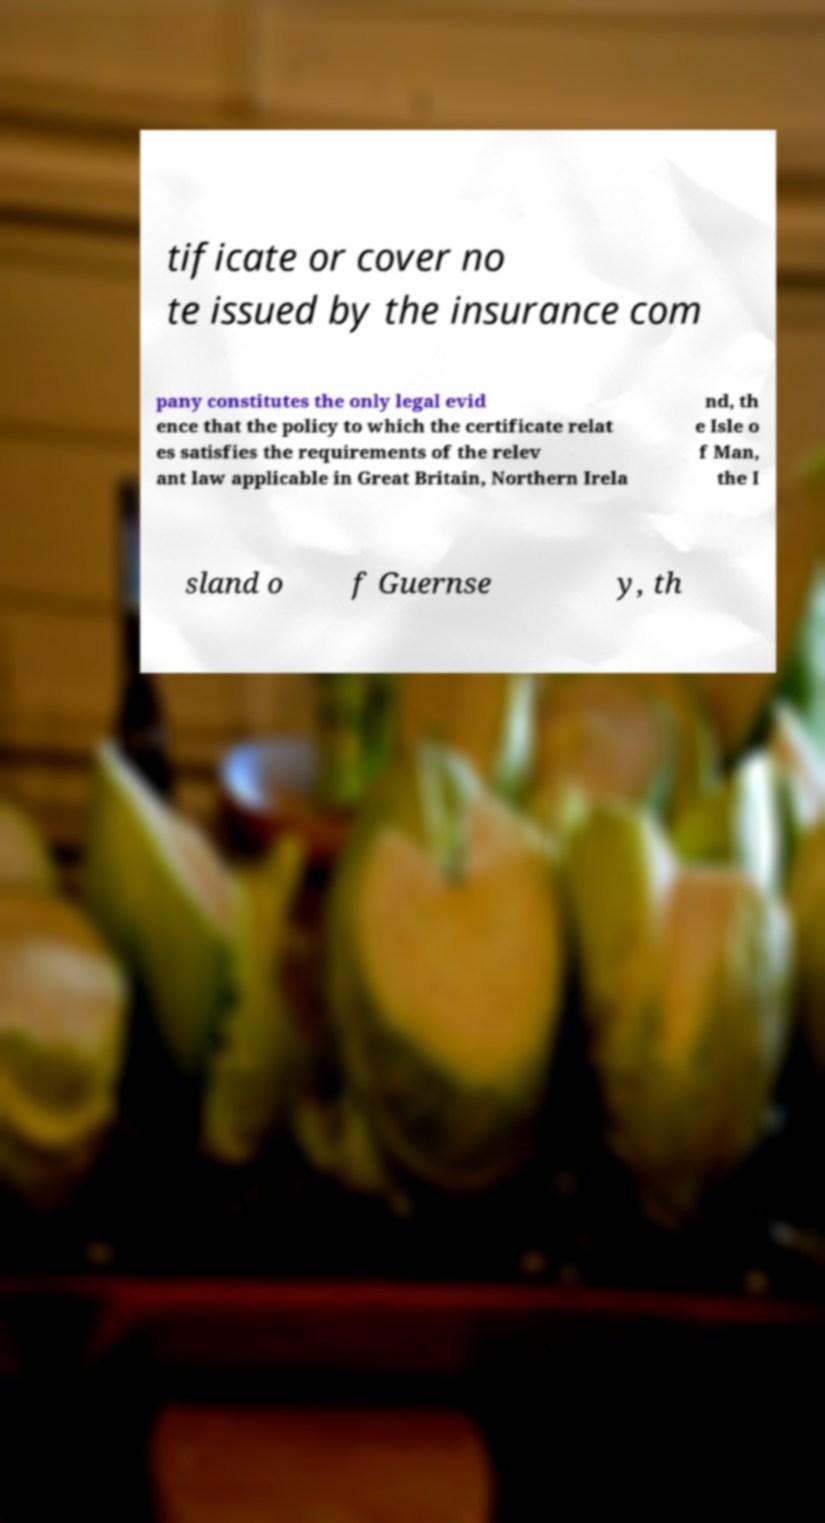Could you assist in decoding the text presented in this image and type it out clearly? tificate or cover no te issued by the insurance com pany constitutes the only legal evid ence that the policy to which the certificate relat es satisfies the requirements of the relev ant law applicable in Great Britain, Northern Irela nd, th e Isle o f Man, the I sland o f Guernse y, th 